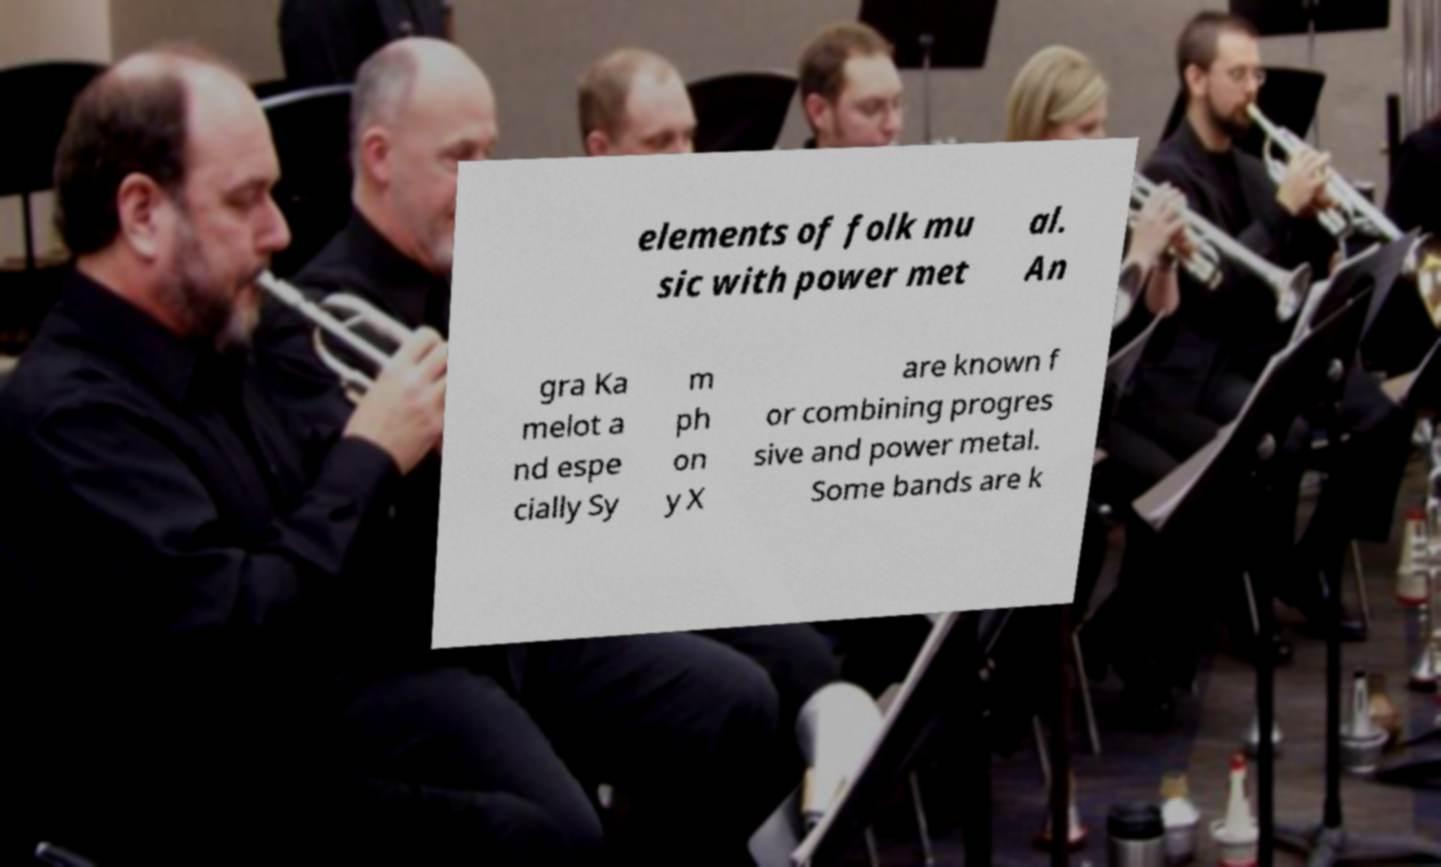Can you accurately transcribe the text from the provided image for me? elements of folk mu sic with power met al. An gra Ka melot a nd espe cially Sy m ph on y X are known f or combining progres sive and power metal. Some bands are k 